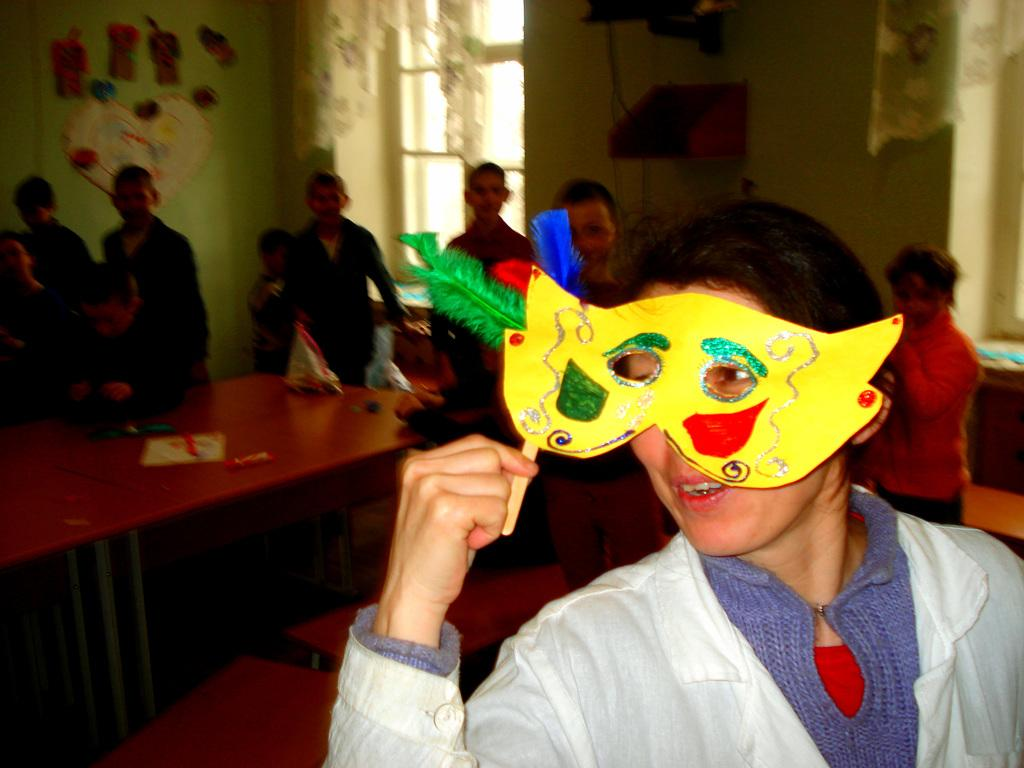What is the main subject of the image? The main subject of the image is a woman. Can you describe the woman's appearance? The woman is wearing a white dress and has short hair. What is the woman holding in the image? The woman is holding a toy. What can be seen in the background of the image? There are many people, a table, a wall, and a window in the background of the image. What is the woman's grandmother doing in the image? There is no mention of a grandmother in the image, so it cannot be determined what she might be doing. How many hands does the woman have in the image? The image does not show the woman's hands, so it cannot be determined how many hands she has. Can you see a toad in the image? There is no toad present in the image. 